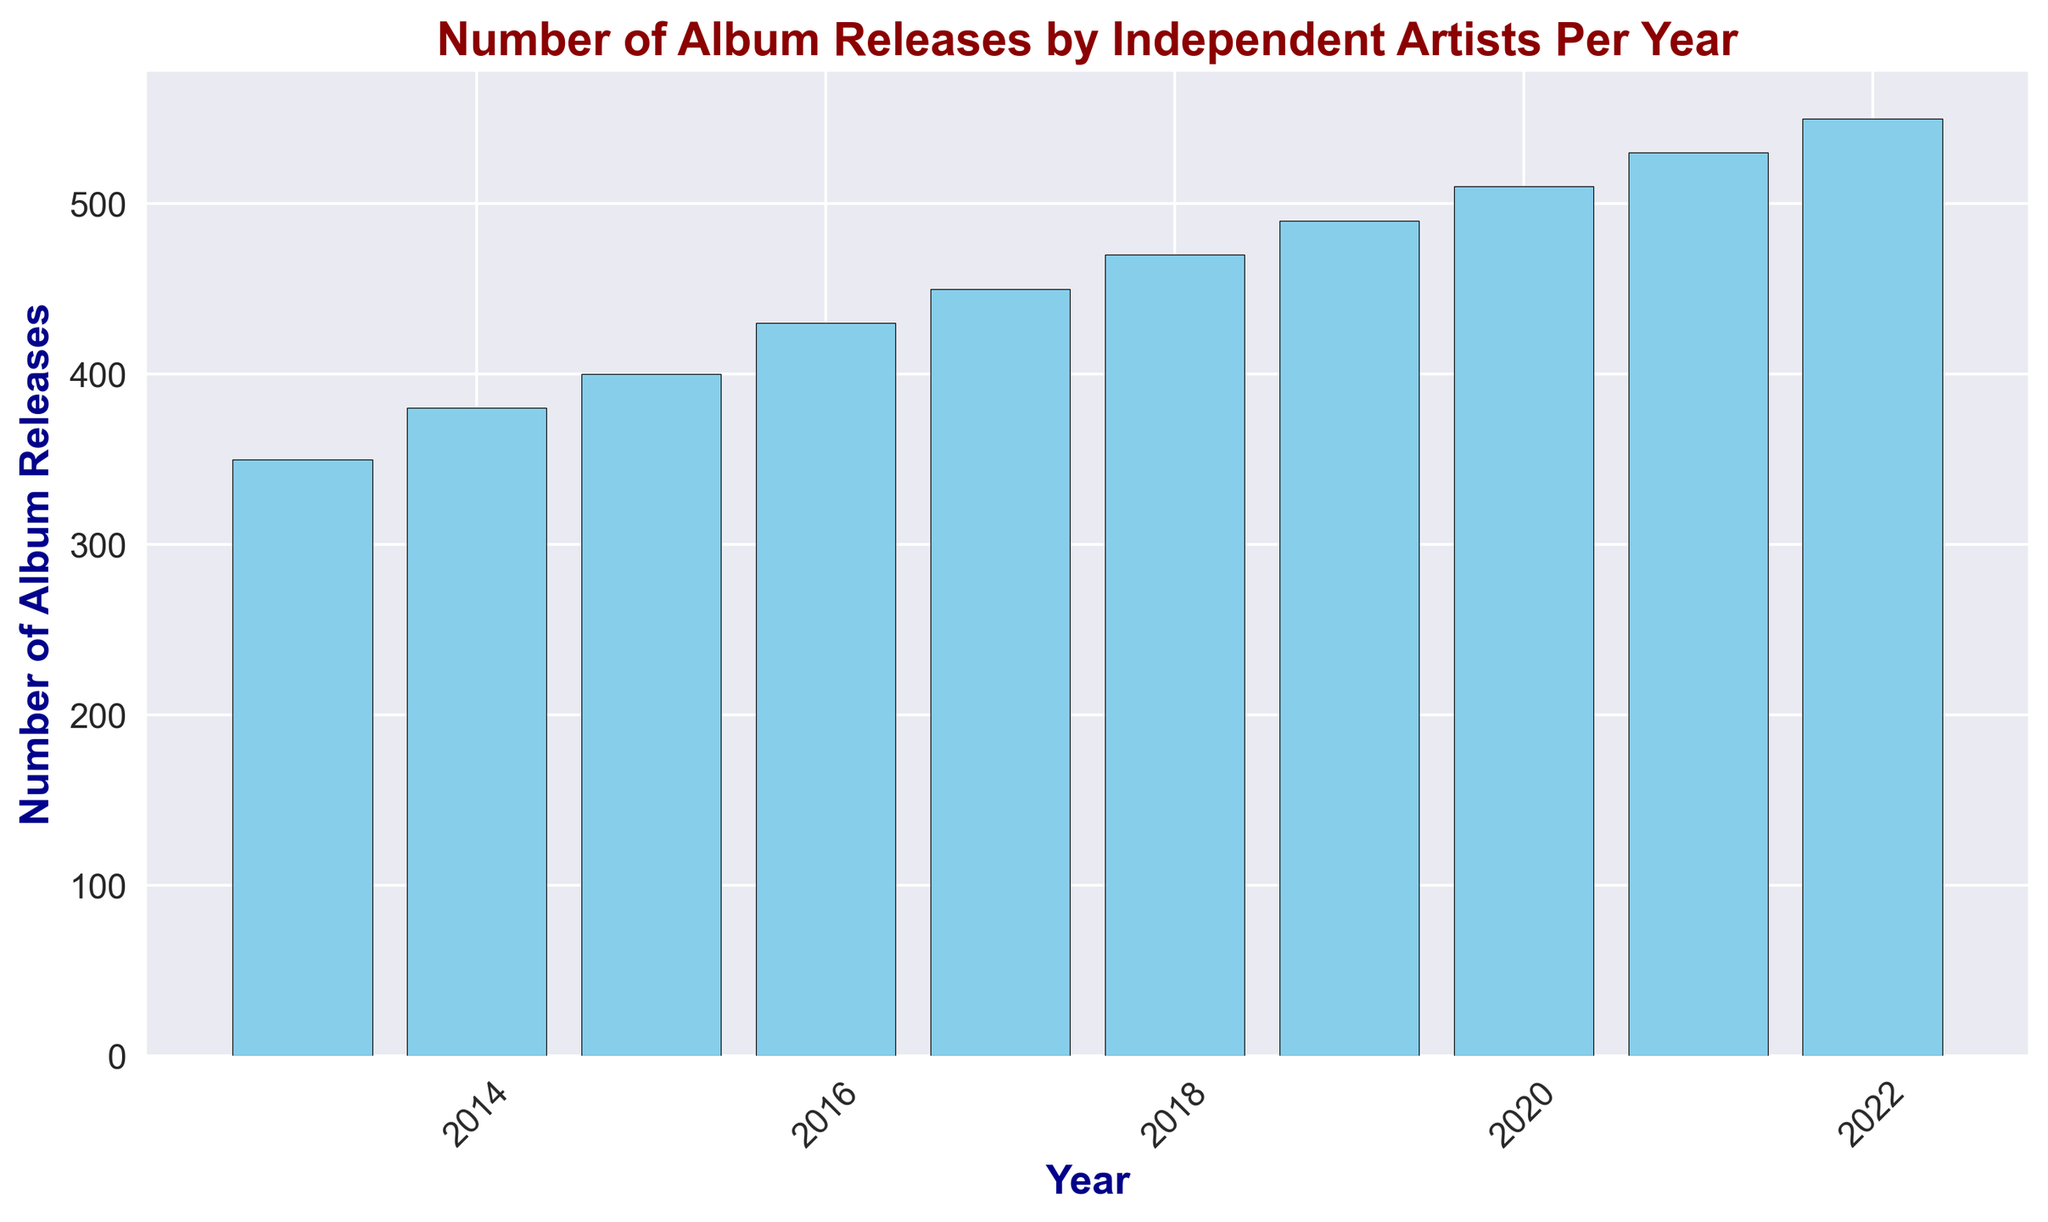Which year had the highest number of album releases? The tallest bar represents the year, which had the highest number of album releases. This bar is in the year 2022.
Answer: 2022 What is the difference in the number of album releases between the years with the highest and lowest releases? The highest number of releases occurred in 2022 with 550 releases, and the lowest occurred in 2013 with 350 releases. The difference is 550 - 350.
Answer: 200 Which years had a number of album releases greater than 500? Locate the bars with heights exceeding the 500 mark on the y-axis. These correspond to the years 2020, 2021, and 2022.
Answer: 2020, 2021, 2022 What is the trend in the number of album releases from 2013 to 2022? Observing the bars from left (2013) to right (2022), there is a clear upward trend, indicating an increase in the number of releases over the years.
Answer: Increasing How many more album releases were there in 2019 compared to 2015? In 2019, there were 490 releases, and in 2015, there were 400 releases. The difference is 490 - 400.
Answer: 90 Which year had the median number of album releases? Sort the years by the number of releases: 350, 380, 400, 430, 450, 470, 490, 510, 530, 550. The median is the middle value, i.e., the 5th and 6th values averaged together, so the median year falls around 2017-2018.
Answer: 2017-2018 By how much did the number of album releases increase from 2016 to 2020? In 2020, there were 510 releases, and in 2016, there were 430 releases. The increase is 510 - 430.
Answer: 80 What is the average number of album releases per year for the last decade? Sum the number of releases from 2013 to 2022 (350 + 380 + 400 + 430 + 450 + 470 + 490 + 510 + 530 + 550) which equals 4560. Then divide by the 10 years. The average is 4560 / 10.
Answer: 456 What year marked the first time the number of album releases exceeded 450? The bar for 2017 is the first to surpass the 450 mark, indicating this was the first year releases exceeded 450.
Answer: 2017 